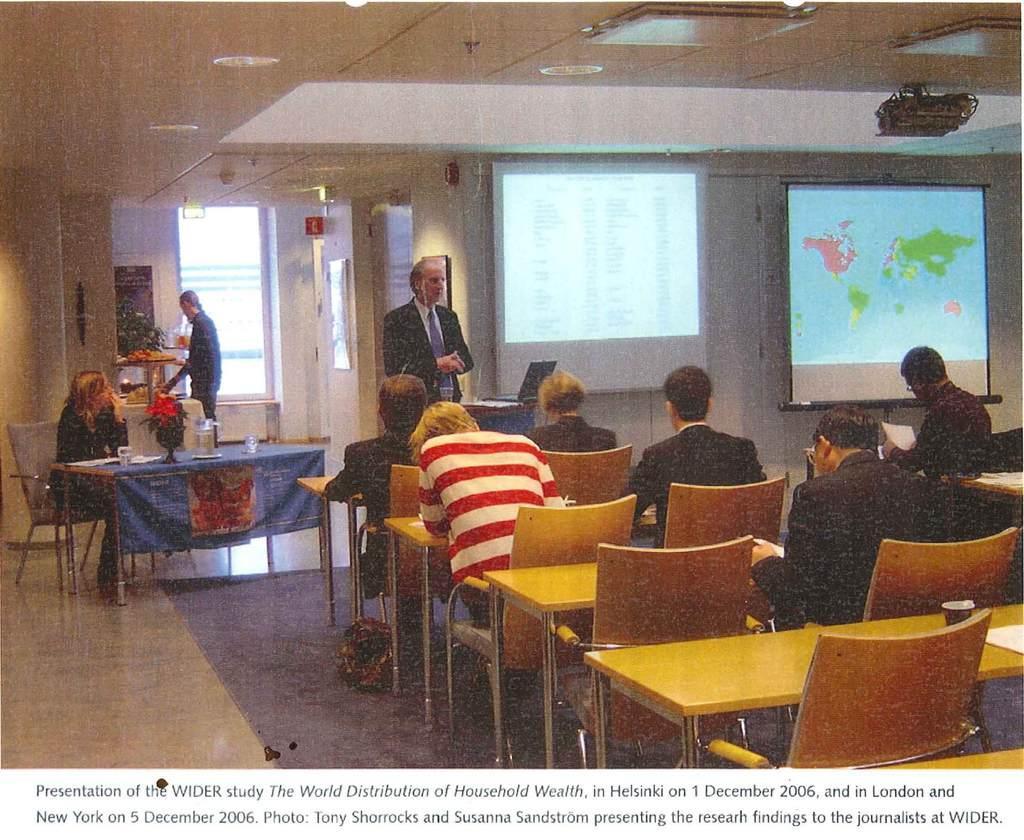Please provide a concise description of this image. Here we can see a few people who are sitting on a chair. There is a person standing in the center and he is speaking,There is a woman sitting on a chair and she is looking at this person. Here we can see a projector and a screen. 